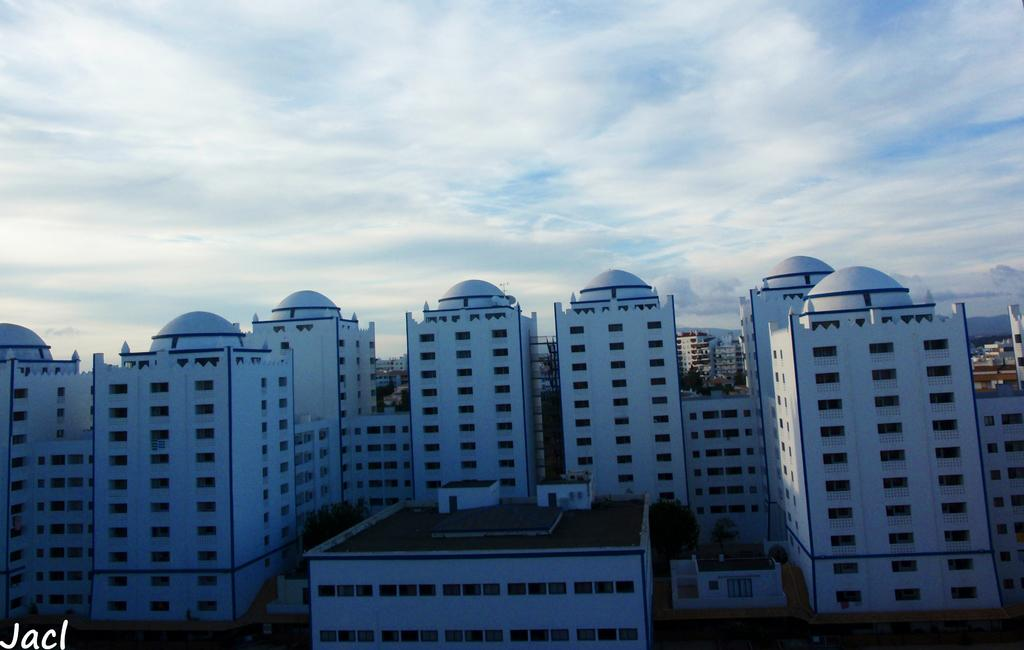What types of structures are visible in the image? There are multiple buildings in the image. What type of clouds can be seen in the image? There is no information about clouds in the image, as the only fact provided is about the presence of multiple buildings. 